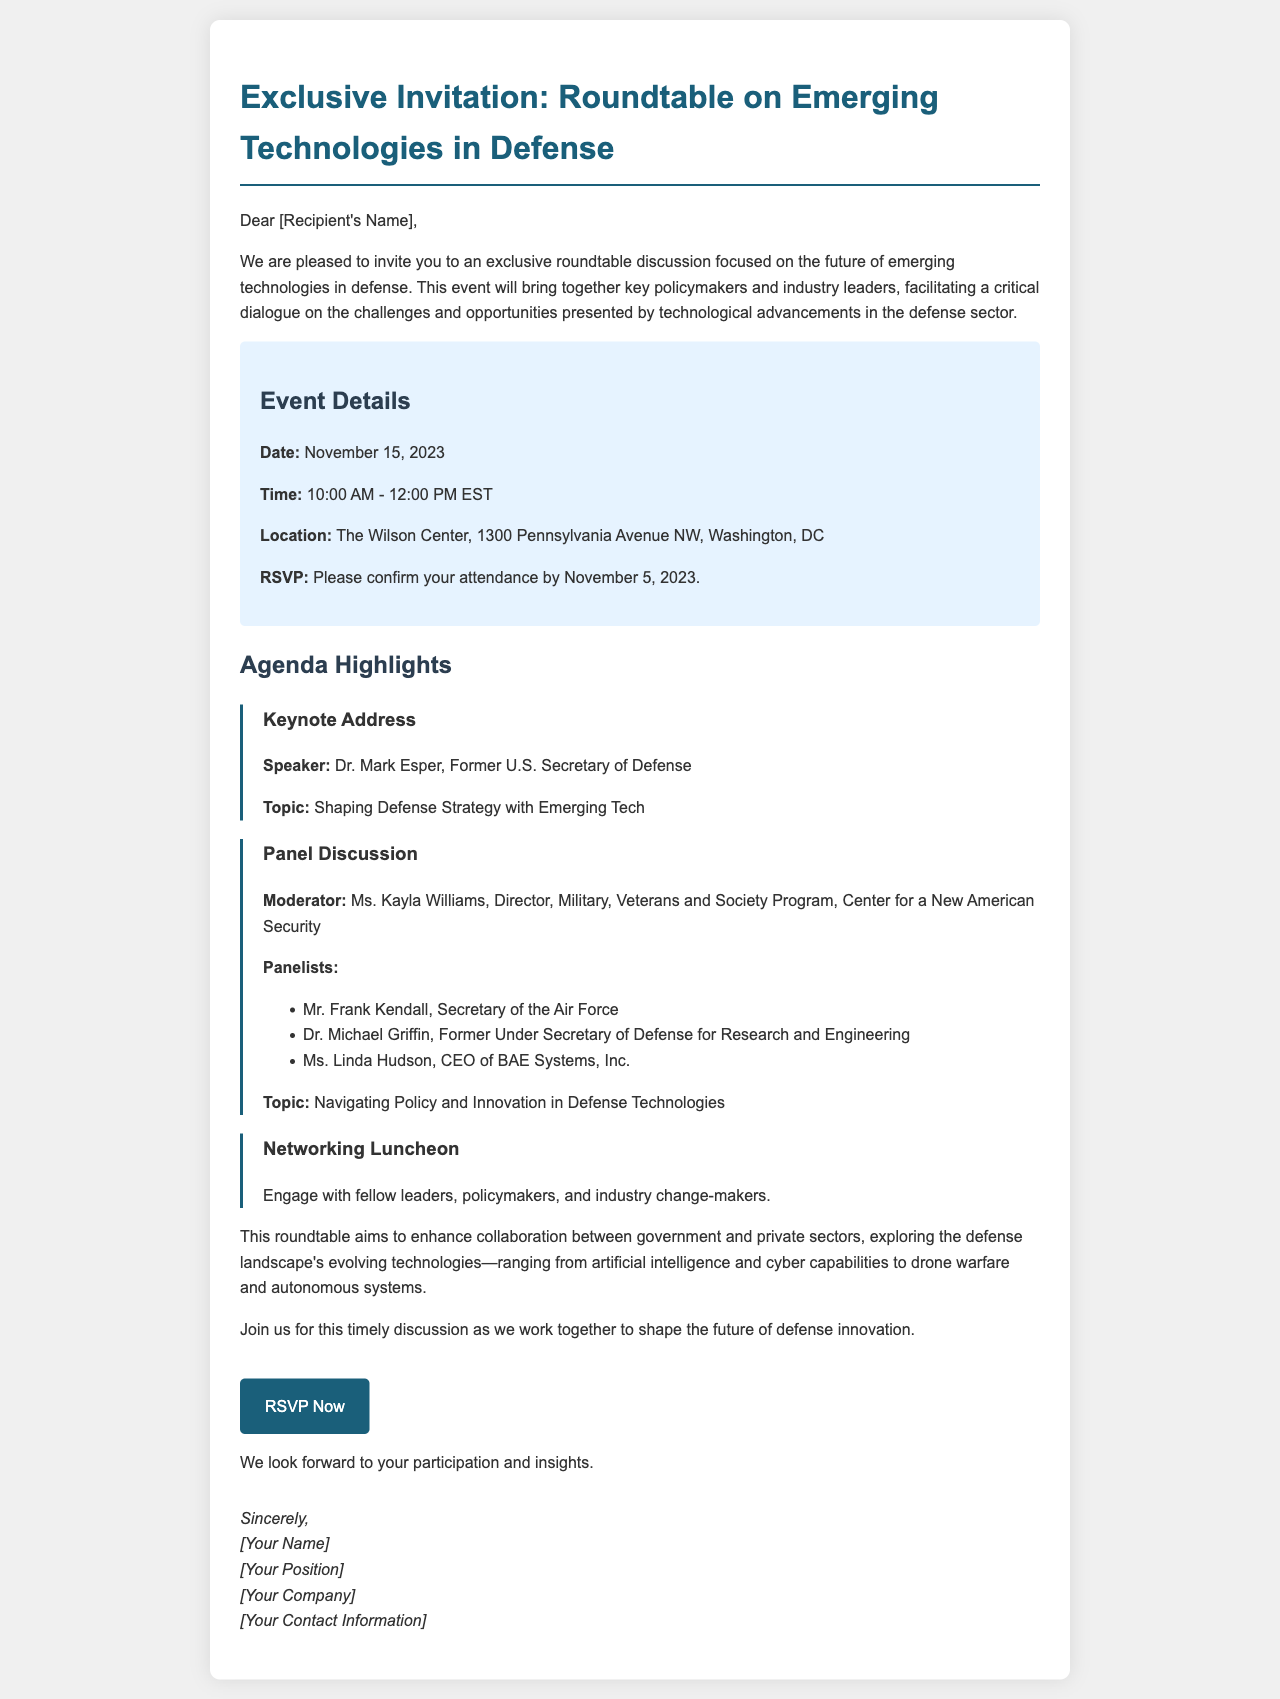What is the date of the event? The event date is clearly stated in the event details section of the document.
Answer: November 15, 2023 Who is the keynote speaker? The keynote address section specifies the speaker's name directly.
Answer: Dr. Mark Esper What is the duration of the event? The time provided in the event details allows us to calculate the event's duration.
Answer: 2 hours Where will the event take place? The location of the event is outlined in the event details section.
Answer: The Wilson Center, 1300 Pennsylvania Avenue NW, Washington, DC What topic will the panel discussion focus on? The topic of the panel discussion is mentioned in the agenda section.
Answer: Navigating Policy and Innovation in Defense Technologies Who will moderate the panel discussion? The name of the moderator for the panel discussion is directly listed in the agenda highlights.
Answer: Ms. Kayla Williams What is the RSVP deadline? The RSVP deadline is explicitly mentioned in the event details section.
Answer: November 5, 2023 What type of event is this document promoting? The introduction of the document outlines the nature of the event.
Answer: Roundtable discussion What is the purpose of the roundtable? The purpose is summarized in the closing paragraphs of the document, focusing on collaboration and technology.
Answer: Enhance collaboration between government and private sectors 